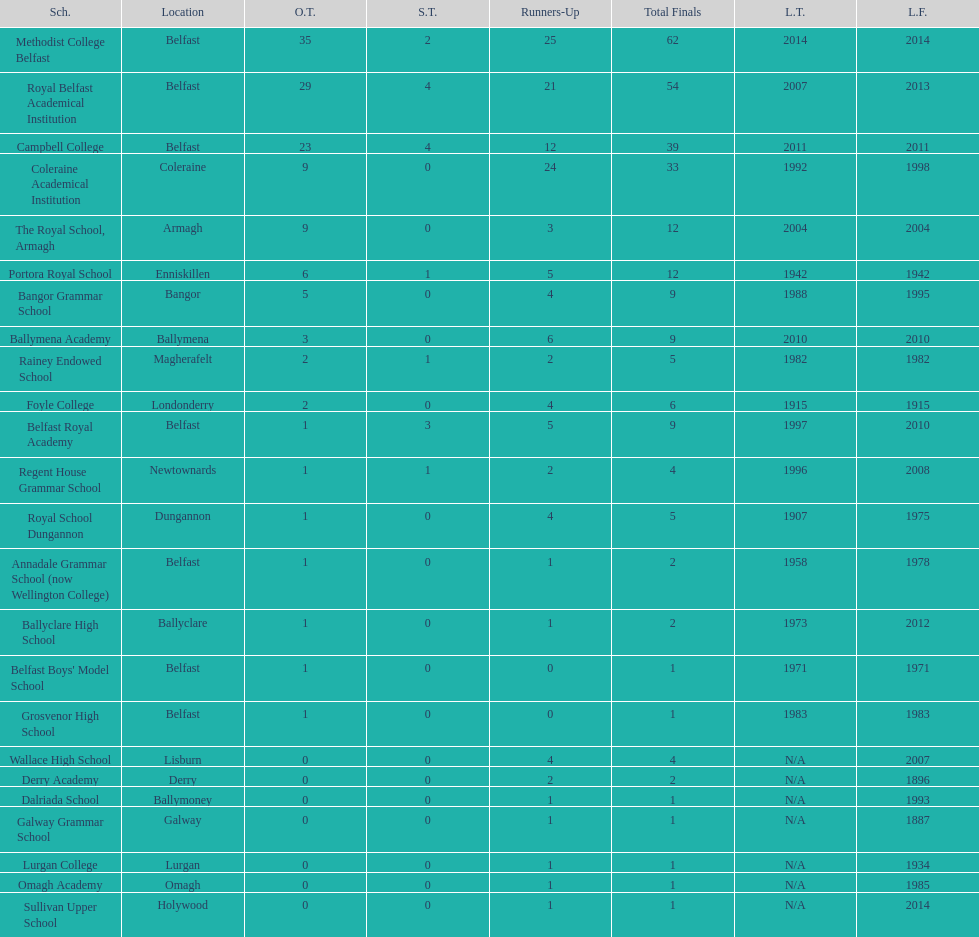Who has the most recent title win, campbell college or regent house grammar school? Campbell College. 